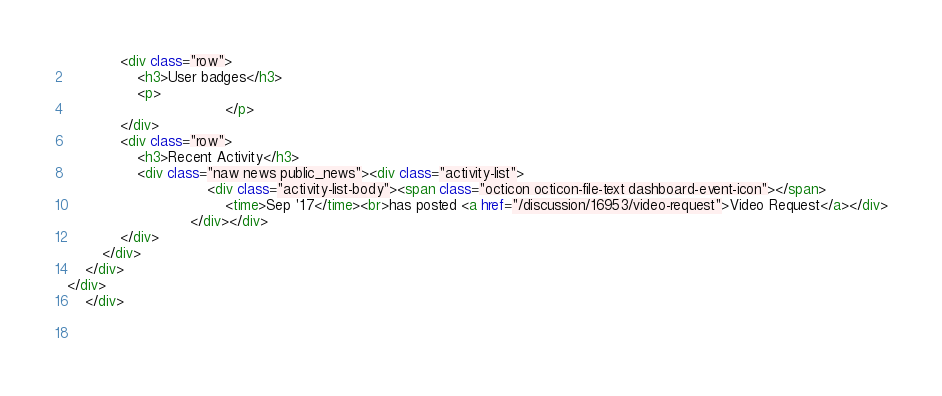<code> <loc_0><loc_0><loc_500><loc_500><_HTML_>            <div class="row">
                <h3>User badges</h3>
                <p>
                                    </p>
            </div>
            <div class="row">
                <h3>Recent Activity</h3>
                <div class="naw news public_news"><div class="activity-list">
                                <div class="activity-list-body"><span class="octicon octicon-file-text dashboard-event-icon"></span>
                                    <time>Sep '17</time><br>has posted <a href="/discussion/16953/video-request">Video Request</a></div>
                            </div></div>
            </div>
        </div>
    </div>
</div>
    </div>

    

</code> 